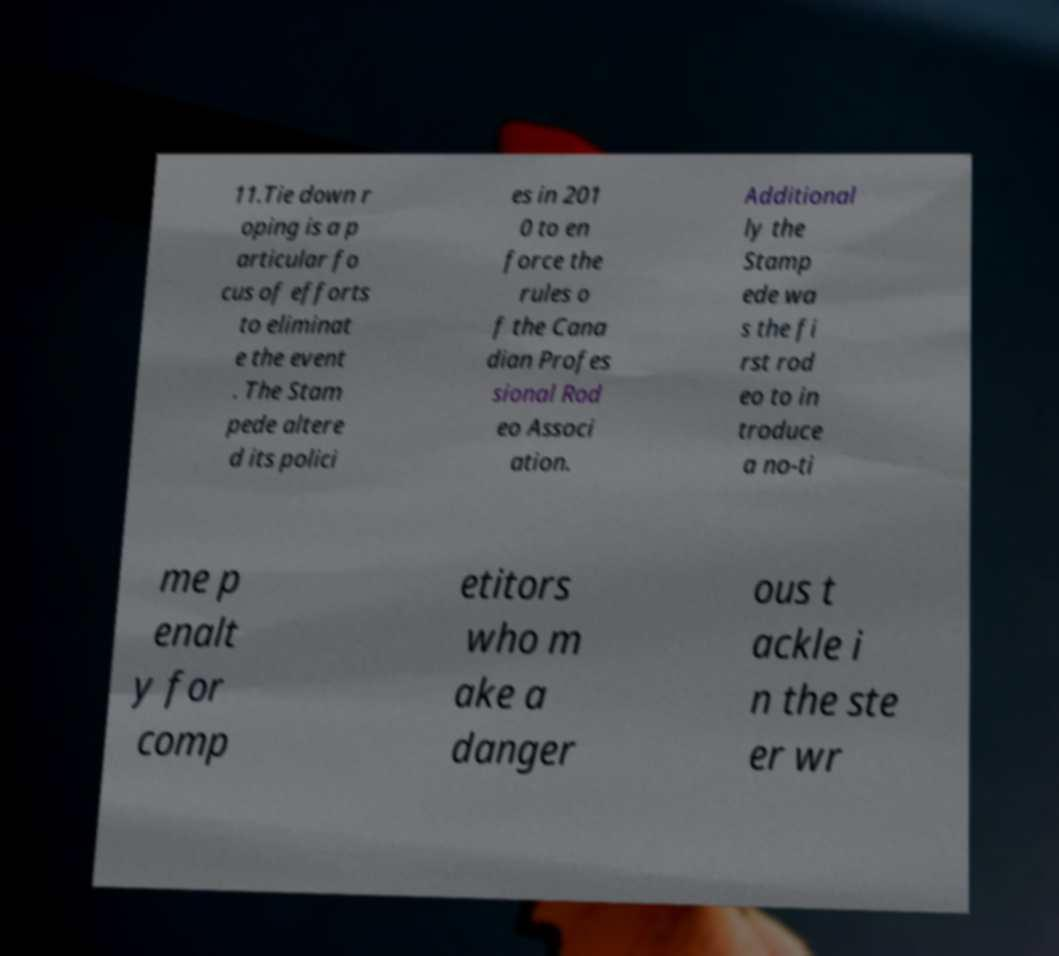Can you accurately transcribe the text from the provided image for me? 11.Tie down r oping is a p articular fo cus of efforts to eliminat e the event . The Stam pede altere d its polici es in 201 0 to en force the rules o f the Cana dian Profes sional Rod eo Associ ation. Additional ly the Stamp ede wa s the fi rst rod eo to in troduce a no-ti me p enalt y for comp etitors who m ake a danger ous t ackle i n the ste er wr 